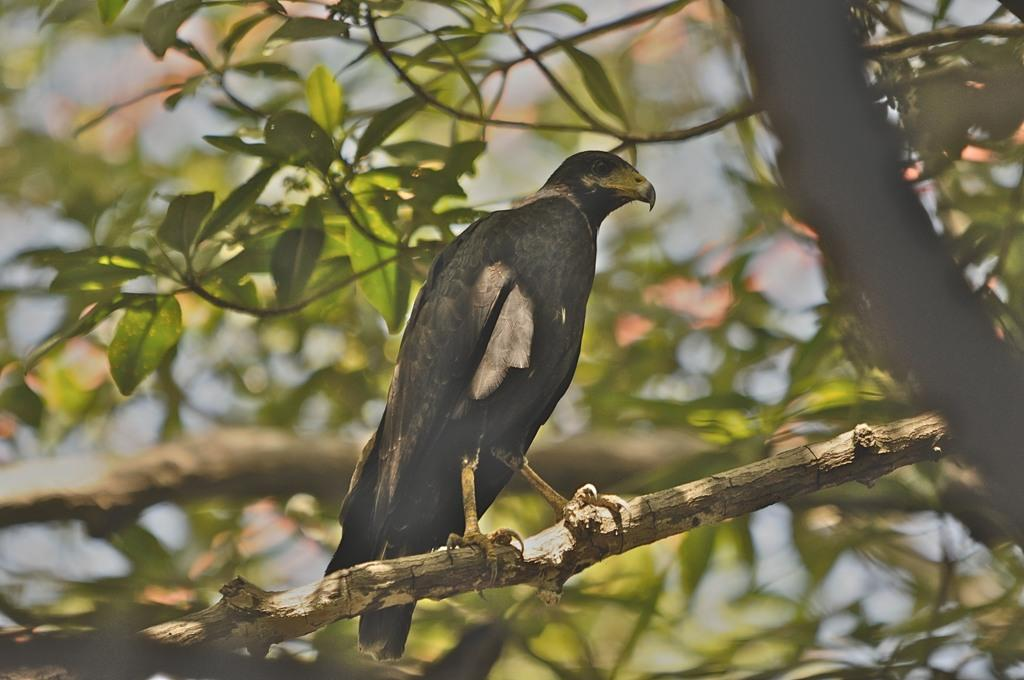What type of animal can be seen in the image? There is a bird in the image. Where is the bird located? The bird is on a tree stem. What can be seen in the background of the image? There are leaves and stems in the background of the image. How is the background of the image depicted? The background has a blurred view. Can you tell me how many strangers are present in the image? There are no strangers present in the image; it features a bird on a tree stem. What type of cork can be seen in the image? There is no cork present in the image. 